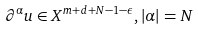<formula> <loc_0><loc_0><loc_500><loc_500>\partial ^ { \alpha } u \in X ^ { m + d + N - 1 - \epsilon } , | \alpha | = N</formula> 